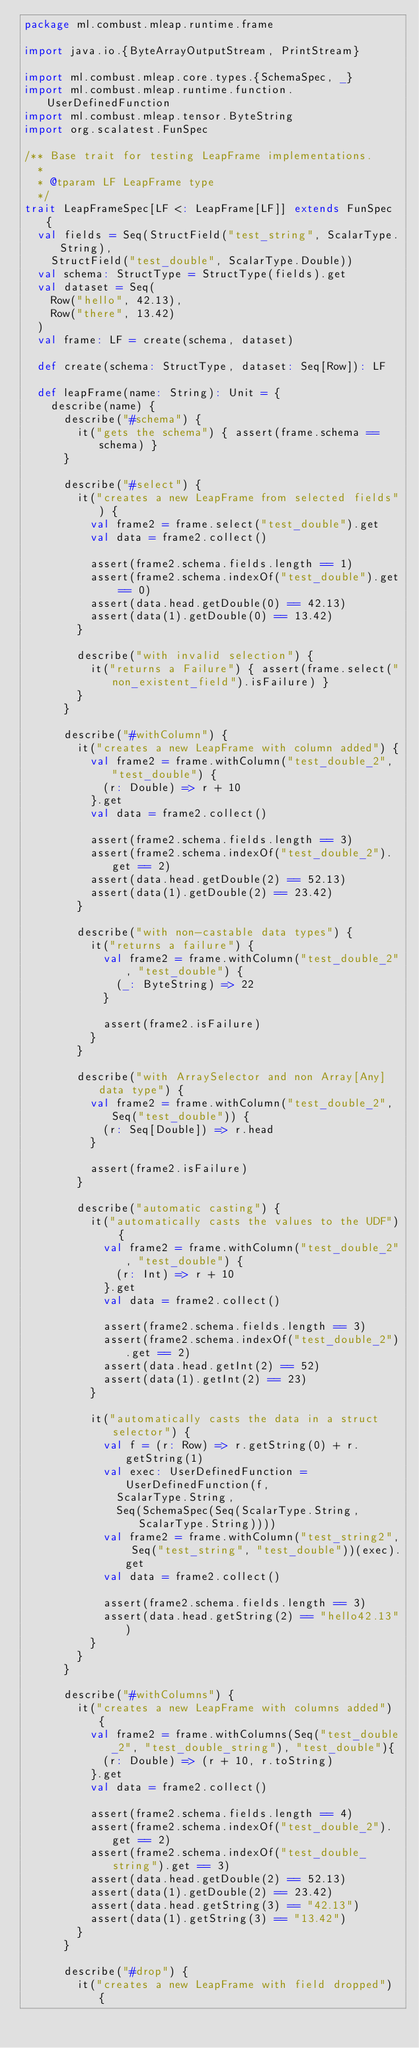Convert code to text. <code><loc_0><loc_0><loc_500><loc_500><_Scala_>package ml.combust.mleap.runtime.frame

import java.io.{ByteArrayOutputStream, PrintStream}

import ml.combust.mleap.core.types.{SchemaSpec, _}
import ml.combust.mleap.runtime.function.UserDefinedFunction
import ml.combust.mleap.tensor.ByteString
import org.scalatest.FunSpec

/** Base trait for testing LeapFrame implementations.
  *
  * @tparam LF LeapFrame type
  */
trait LeapFrameSpec[LF <: LeapFrame[LF]] extends FunSpec {
  val fields = Seq(StructField("test_string", ScalarType.String),
    StructField("test_double", ScalarType.Double))
  val schema: StructType = StructType(fields).get
  val dataset = Seq(
    Row("hello", 42.13),
    Row("there", 13.42)
  )
  val frame: LF = create(schema, dataset)

  def create(schema: StructType, dataset: Seq[Row]): LF

  def leapFrame(name: String): Unit = {
    describe(name) {
      describe("#schema") {
        it("gets the schema") { assert(frame.schema == schema) }
      }

      describe("#select") {
        it("creates a new LeapFrame from selected fields") {
          val frame2 = frame.select("test_double").get
          val data = frame2.collect()

          assert(frame2.schema.fields.length == 1)
          assert(frame2.schema.indexOf("test_double").get == 0)
          assert(data.head.getDouble(0) == 42.13)
          assert(data(1).getDouble(0) == 13.42)
        }

        describe("with invalid selection") {
          it("returns a Failure") { assert(frame.select("non_existent_field").isFailure) }
        }
      }

      describe("#withColumn") {
        it("creates a new LeapFrame with column added") {
          val frame2 = frame.withColumn("test_double_2", "test_double") {
            (r: Double) => r + 10
          }.get
          val data = frame2.collect()

          assert(frame2.schema.fields.length == 3)
          assert(frame2.schema.indexOf("test_double_2").get == 2)
          assert(data.head.getDouble(2) == 52.13)
          assert(data(1).getDouble(2) == 23.42)
        }

        describe("with non-castable data types") {
          it("returns a failure") {
            val frame2 = frame.withColumn("test_double_2", "test_double") {
              (_: ByteString) => 22
            }

            assert(frame2.isFailure)
          }
        }

        describe("with ArraySelector and non Array[Any] data type") {
          val frame2 = frame.withColumn("test_double_2", Seq("test_double")) {
            (r: Seq[Double]) => r.head
          }

          assert(frame2.isFailure)
        }

        describe("automatic casting") {
          it("automatically casts the values to the UDF") {
            val frame2 = frame.withColumn("test_double_2", "test_double") {
              (r: Int) => r + 10
            }.get
            val data = frame2.collect()

            assert(frame2.schema.fields.length == 3)
            assert(frame2.schema.indexOf("test_double_2").get == 2)
            assert(data.head.getInt(2) == 52)
            assert(data(1).getInt(2) == 23)
          }

          it("automatically casts the data in a struct selector") {
            val f = (r: Row) => r.getString(0) + r.getString(1)
            val exec: UserDefinedFunction = UserDefinedFunction(f,
              ScalarType.String,
              Seq(SchemaSpec(Seq(ScalarType.String, ScalarType.String))))
            val frame2 = frame.withColumn("test_string2", Seq("test_string", "test_double"))(exec).get
            val data = frame2.collect()

            assert(frame2.schema.fields.length == 3)
            assert(data.head.getString(2) == "hello42.13")
          }
        }
      }

      describe("#withColumns") {
        it("creates a new LeapFrame with columns added") {
          val frame2 = frame.withColumns(Seq("test_double_2", "test_double_string"), "test_double"){
            (r: Double) => (r + 10, r.toString)
          }.get
          val data = frame2.collect()

          assert(frame2.schema.fields.length == 4)
          assert(frame2.schema.indexOf("test_double_2").get == 2)
          assert(frame2.schema.indexOf("test_double_string").get == 3)
          assert(data.head.getDouble(2) == 52.13)
          assert(data(1).getDouble(2) == 23.42)
          assert(data.head.getString(3) == "42.13")
          assert(data(1).getString(3) == "13.42")
        }
      }

      describe("#drop") {
        it("creates a new LeapFrame with field dropped") {</code> 